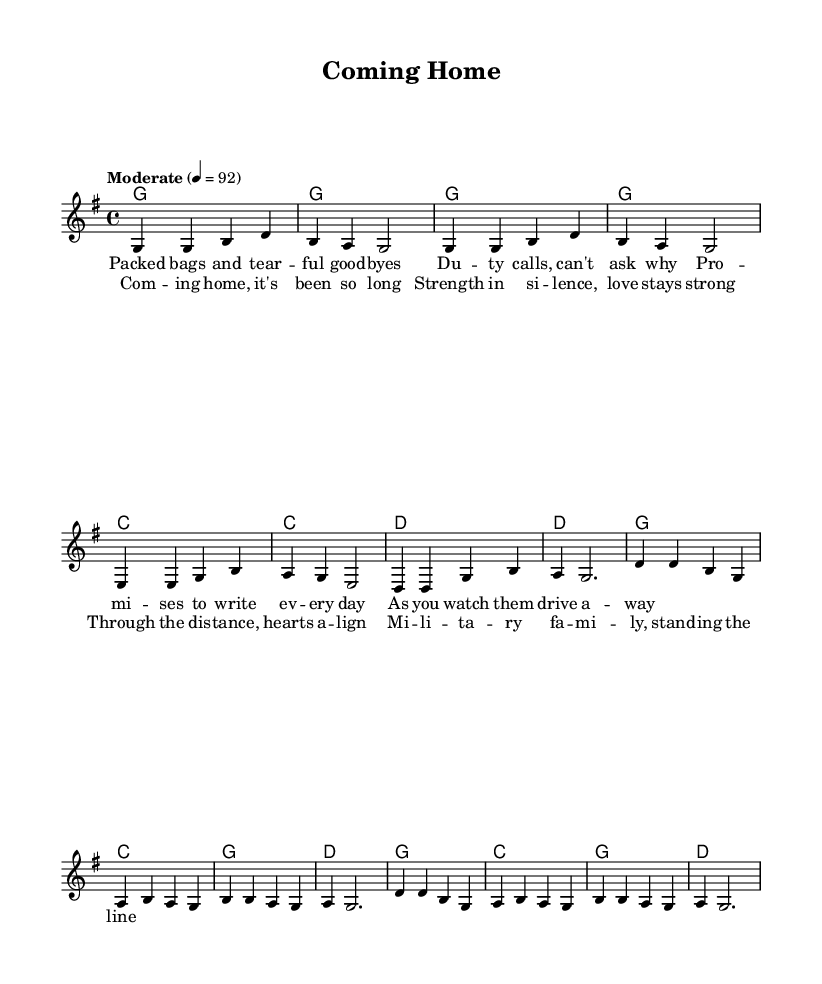what is the key signature of this music? The key signature is G major, which has one sharp (F#). This is indicated at the beginning of the staff.
Answer: G major what is the time signature of this music? The time signature is 4/4, which means there are four beats in each measure and a quarter note receives one beat. This is shown at the beginning of the music.
Answer: 4/4 what is the tempo marking for this piece? The tempo marking is "Moderate" with a metronome marking of 92 beats per minute. This indicates the speed at which the piece should be played.
Answer: Moderate 92 how many measures are in the verse section? The verse section consists of 8 measures. By counting the measures notated, we find there are 8 distinct entries for the melody in the verse section.
Answer: 8 which family themes are addressed in the chorus of this song? The chorus addresses themes of love, distance, and military families standing strong. Analyzing the lyrics shows that these themes reflect the emotional bonds and resilience of military families.
Answer: love, distance, military families how many unique chords are used throughout the piece? There are three unique chords used throughout the piece: G major, C major, and D major. By examining the chord symbols in the harmonic notation, we can identify these chords.
Answer: three what is the structure of the song based on the sections provided? The song structure includes a verse followed by a chorus and likely repeats. The arrangement of the melody and lyrics indicates a typical verse-chorus structure commonly found in country music.
Answer: verse-chorus 